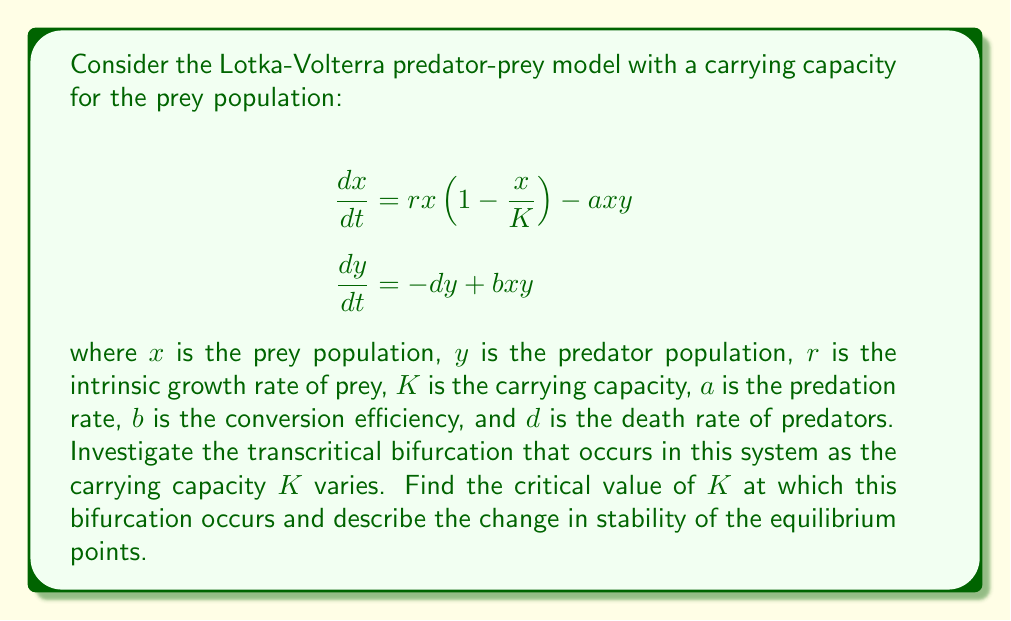Can you solve this math problem? To investigate the transcritical bifurcation, we follow these steps:

1) First, find the equilibrium points by setting the derivatives to zero:

   $$rx(1-\frac{x}{K}) - axy = 0$$
   $$-dy + bxy = 0$$

2) From the second equation, we get $y = 0$ or $x = \frac{d}{b}$.

3) If $y = 0$, from the first equation we get $x = 0$ or $x = K$.

4) If $x = \frac{d}{b}$, substituting into the first equation:

   $$r\frac{d}{b}(1-\frac{d}{bK}) - a\frac{d}{b}y = 0$$
   $$y = \frac{r}{a}(1-\frac{d}{bK})$$

5) Therefore, we have three equilibrium points:
   
   $E_1: (0,0)$
   $E_2: (K,0)$
   $E_3: (\frac{d}{b}, \frac{r}{a}(1-\frac{d}{bK}))$

6) The transcritical bifurcation occurs when $E_3$ intersects with $E_2$, i.e., when $\frac{d}{b} = K$.

7) Solving this, we get the critical value: $K_c = \frac{d}{b}$

8) For $K < K_c$, $E_2$ is stable and $E_3$ is not biologically meaningful (negative $y$).
   For $K > K_c$, $E_3$ becomes biologically meaningful and stable, while $E_2$ becomes unstable.

9) This exchange of stability at $K = K_c$ characterizes the transcritical bifurcation.
Answer: $K_c = \frac{d}{b}$ 